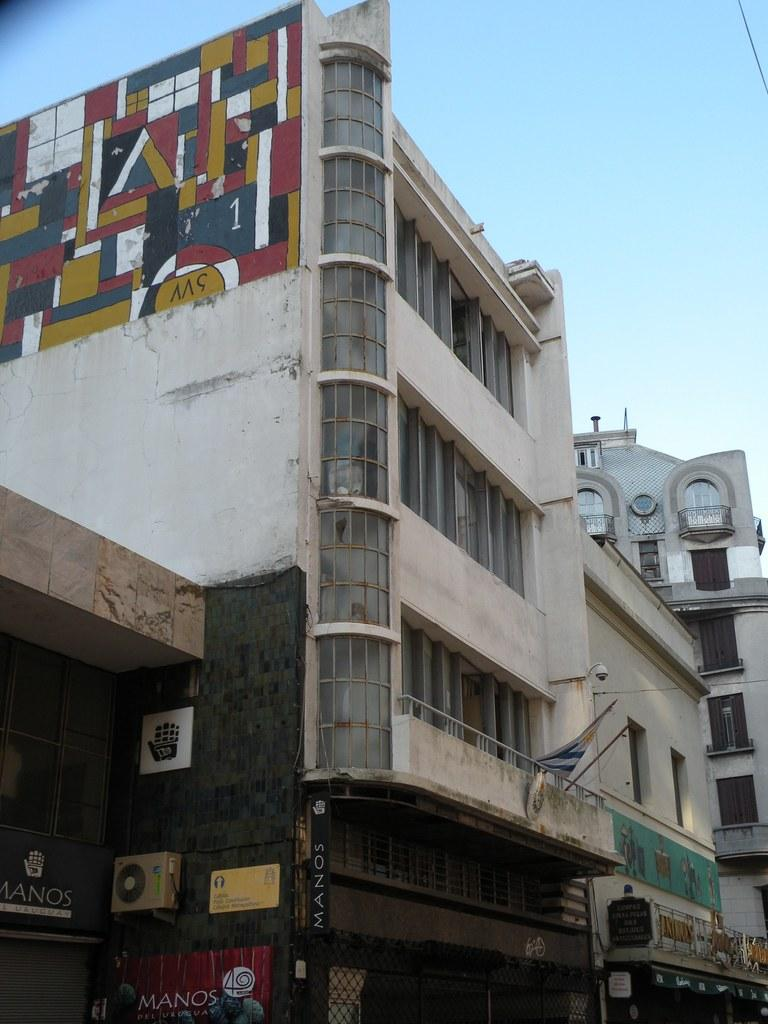What type of structures can be seen in the image? There are buildings in the image. What is attached to the buildings? Boards are attached to the buildings. What can be seen flying in the image? There is a flag visible in the image. What is visible above the buildings? The sky is visible in the image. What type of bean is growing on the flag in the image? There are no beans present in the image, and the flag is not associated with any bean growth. 